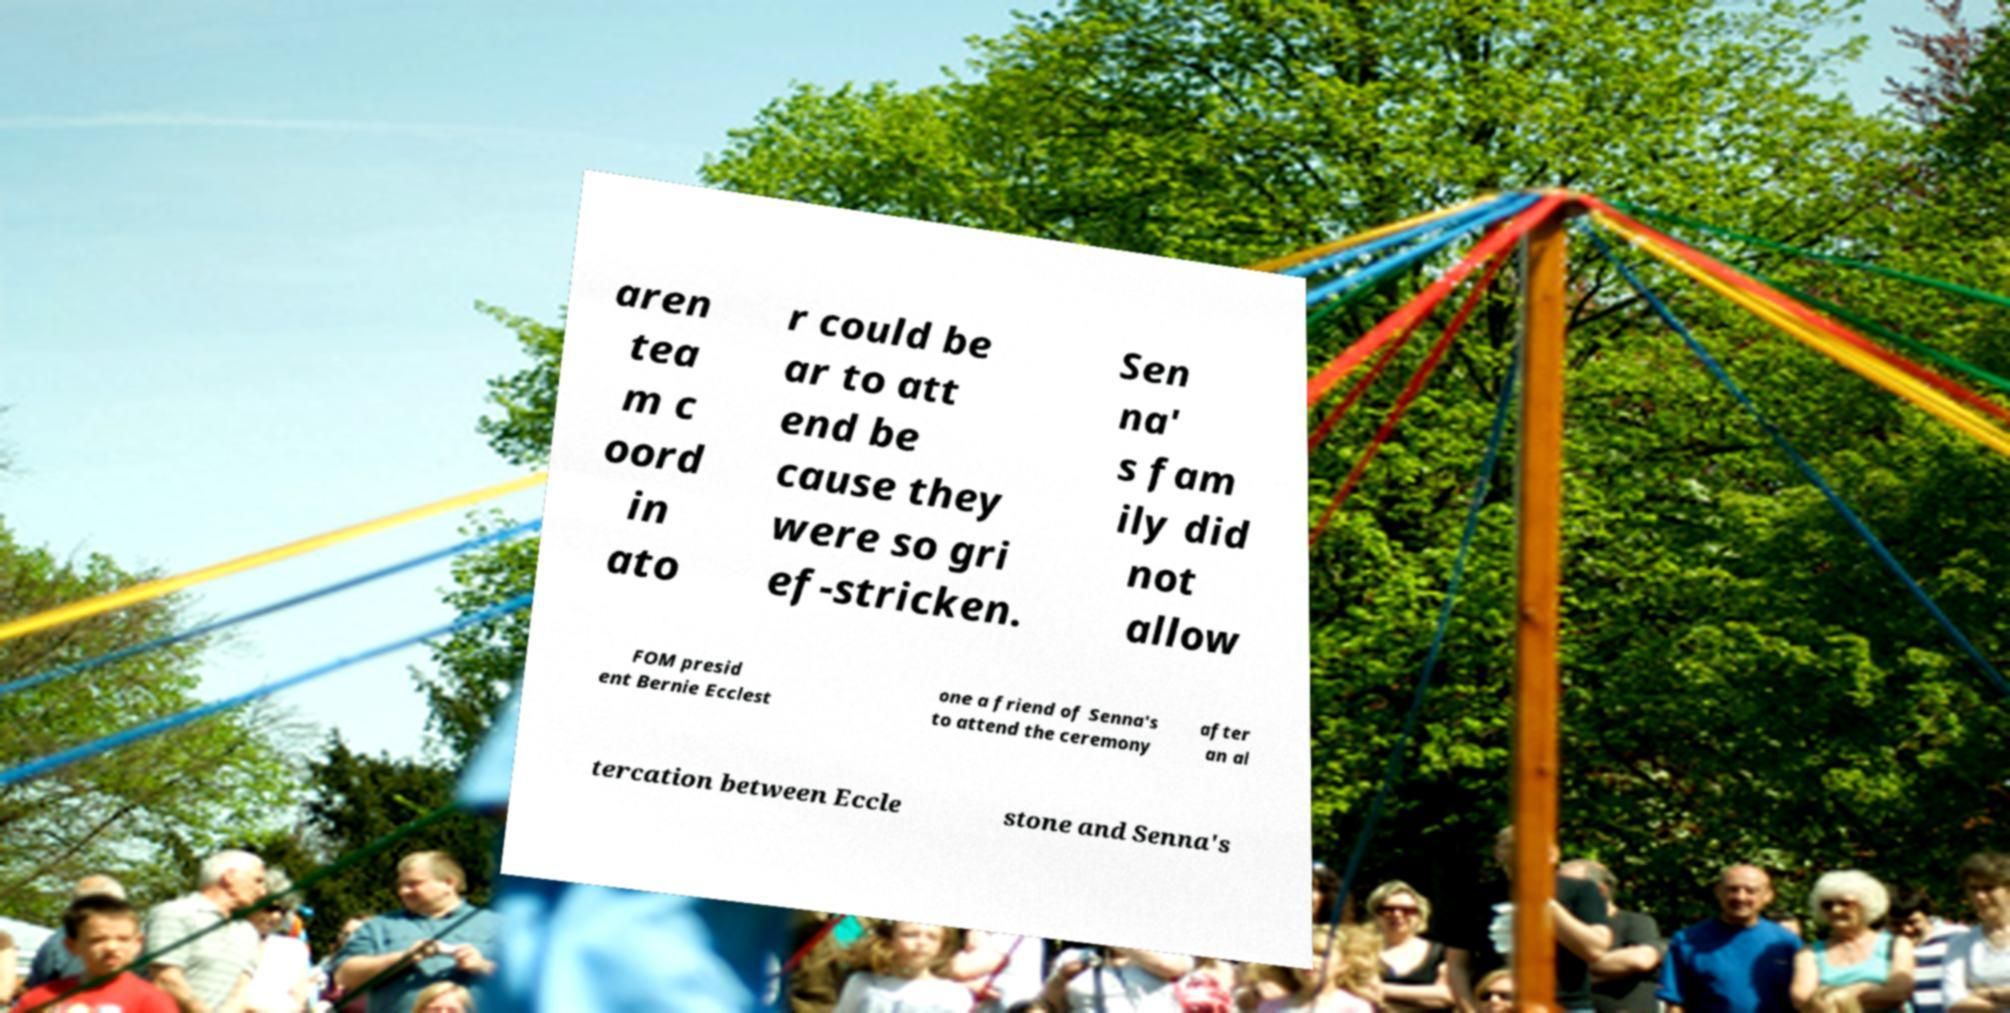Please read and relay the text visible in this image. What does it say? aren tea m c oord in ato r could be ar to att end be cause they were so gri ef-stricken. Sen na' s fam ily did not allow FOM presid ent Bernie Ecclest one a friend of Senna's to attend the ceremony after an al tercation between Eccle stone and Senna's 